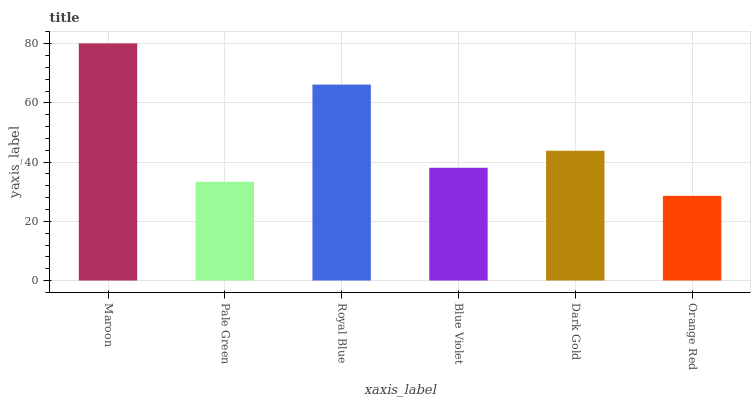Is Orange Red the minimum?
Answer yes or no. Yes. Is Maroon the maximum?
Answer yes or no. Yes. Is Pale Green the minimum?
Answer yes or no. No. Is Pale Green the maximum?
Answer yes or no. No. Is Maroon greater than Pale Green?
Answer yes or no. Yes. Is Pale Green less than Maroon?
Answer yes or no. Yes. Is Pale Green greater than Maroon?
Answer yes or no. No. Is Maroon less than Pale Green?
Answer yes or no. No. Is Dark Gold the high median?
Answer yes or no. Yes. Is Blue Violet the low median?
Answer yes or no. Yes. Is Orange Red the high median?
Answer yes or no. No. Is Dark Gold the low median?
Answer yes or no. No. 